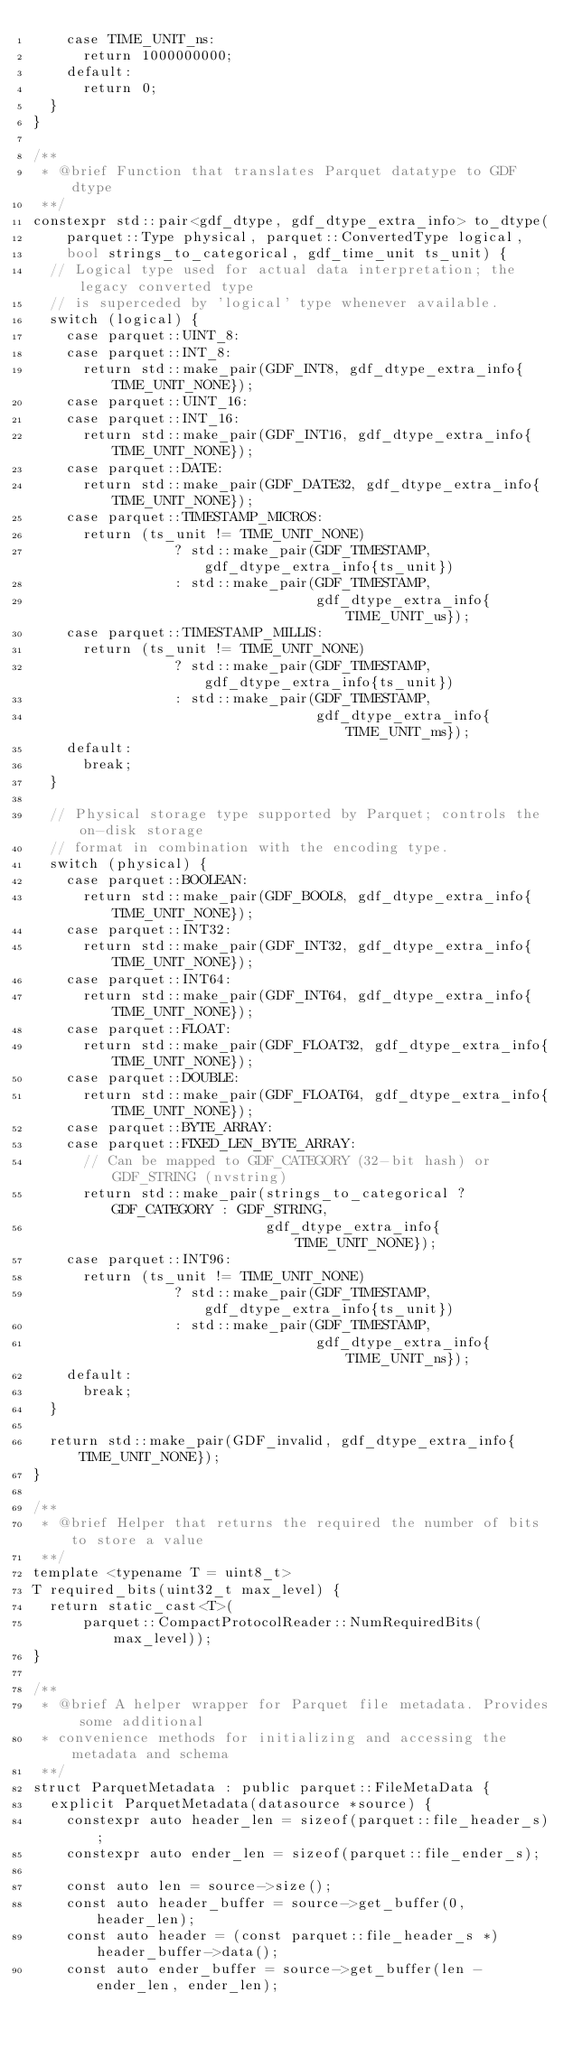<code> <loc_0><loc_0><loc_500><loc_500><_Cuda_>    case TIME_UNIT_ns:
      return 1000000000;
    default:
      return 0;
  }
}

/**
 * @brief Function that translates Parquet datatype to GDF dtype
 **/
constexpr std::pair<gdf_dtype, gdf_dtype_extra_info> to_dtype(
    parquet::Type physical, parquet::ConvertedType logical,
    bool strings_to_categorical, gdf_time_unit ts_unit) {
  // Logical type used for actual data interpretation; the legacy converted type
  // is superceded by 'logical' type whenever available.
  switch (logical) {
    case parquet::UINT_8:
    case parquet::INT_8:
      return std::make_pair(GDF_INT8, gdf_dtype_extra_info{TIME_UNIT_NONE});
    case parquet::UINT_16:
    case parquet::INT_16:
      return std::make_pair(GDF_INT16, gdf_dtype_extra_info{TIME_UNIT_NONE});
    case parquet::DATE:
      return std::make_pair(GDF_DATE32, gdf_dtype_extra_info{TIME_UNIT_NONE});
    case parquet::TIMESTAMP_MICROS:
      return (ts_unit != TIME_UNIT_NONE)
                 ? std::make_pair(GDF_TIMESTAMP, gdf_dtype_extra_info{ts_unit})
                 : std::make_pair(GDF_TIMESTAMP,
                                  gdf_dtype_extra_info{TIME_UNIT_us});
    case parquet::TIMESTAMP_MILLIS:
      return (ts_unit != TIME_UNIT_NONE)
                 ? std::make_pair(GDF_TIMESTAMP, gdf_dtype_extra_info{ts_unit})
                 : std::make_pair(GDF_TIMESTAMP,
                                  gdf_dtype_extra_info{TIME_UNIT_ms});
    default:
      break;
  }

  // Physical storage type supported by Parquet; controls the on-disk storage
  // format in combination with the encoding type.
  switch (physical) {
    case parquet::BOOLEAN:
      return std::make_pair(GDF_BOOL8, gdf_dtype_extra_info{TIME_UNIT_NONE});
    case parquet::INT32:
      return std::make_pair(GDF_INT32, gdf_dtype_extra_info{TIME_UNIT_NONE});
    case parquet::INT64:
      return std::make_pair(GDF_INT64, gdf_dtype_extra_info{TIME_UNIT_NONE});
    case parquet::FLOAT:
      return std::make_pair(GDF_FLOAT32, gdf_dtype_extra_info{TIME_UNIT_NONE});
    case parquet::DOUBLE:
      return std::make_pair(GDF_FLOAT64, gdf_dtype_extra_info{TIME_UNIT_NONE});
    case parquet::BYTE_ARRAY:
    case parquet::FIXED_LEN_BYTE_ARRAY:
      // Can be mapped to GDF_CATEGORY (32-bit hash) or GDF_STRING (nvstring)
      return std::make_pair(strings_to_categorical ? GDF_CATEGORY : GDF_STRING,
                            gdf_dtype_extra_info{TIME_UNIT_NONE});
    case parquet::INT96:
      return (ts_unit != TIME_UNIT_NONE)
                 ? std::make_pair(GDF_TIMESTAMP, gdf_dtype_extra_info{ts_unit})
                 : std::make_pair(GDF_TIMESTAMP,
                                  gdf_dtype_extra_info{TIME_UNIT_ns});
    default:
      break;
  }

  return std::make_pair(GDF_invalid, gdf_dtype_extra_info{TIME_UNIT_NONE});
}

/**
 * @brief Helper that returns the required the number of bits to store a value
 **/
template <typename T = uint8_t>
T required_bits(uint32_t max_level) {
  return static_cast<T>(
      parquet::CompactProtocolReader::NumRequiredBits(max_level));
}

/**
 * @brief A helper wrapper for Parquet file metadata. Provides some additional
 * convenience methods for initializing and accessing the metadata and schema
 **/
struct ParquetMetadata : public parquet::FileMetaData {
  explicit ParquetMetadata(datasource *source) {
    constexpr auto header_len = sizeof(parquet::file_header_s);
    constexpr auto ender_len = sizeof(parquet::file_ender_s);

    const auto len = source->size();
    const auto header_buffer = source->get_buffer(0, header_len);
    const auto header = (const parquet::file_header_s *)header_buffer->data();
    const auto ender_buffer = source->get_buffer(len - ender_len, ender_len);</code> 